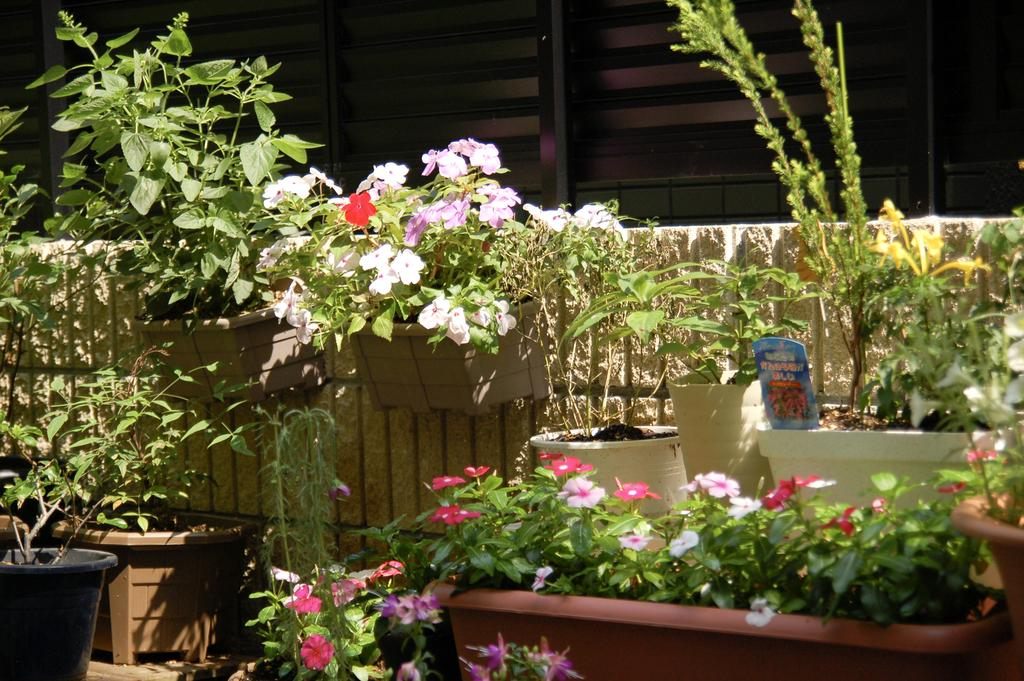What is the main subject of the image? The main subject of the image is the many plants. Can you describe any specific objects related to the plants? Yes, there is a pot in the image. What can be observed about the flowers in the image? There are flowers of different colors in the image. What type of insect is crawling on the veil in the image? There is no insect or veil present in the image; it features many plants and flowers. 